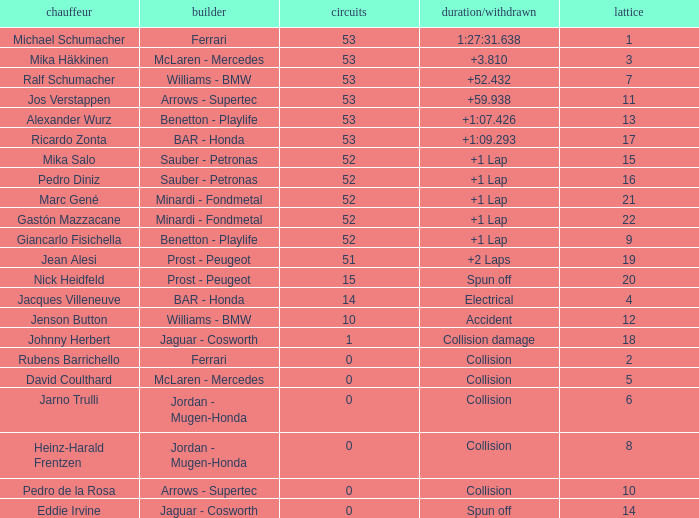What is the grid number with less than 52 laps and a Time/Retired of collision, and a Constructor of arrows - supertec? 1.0. 